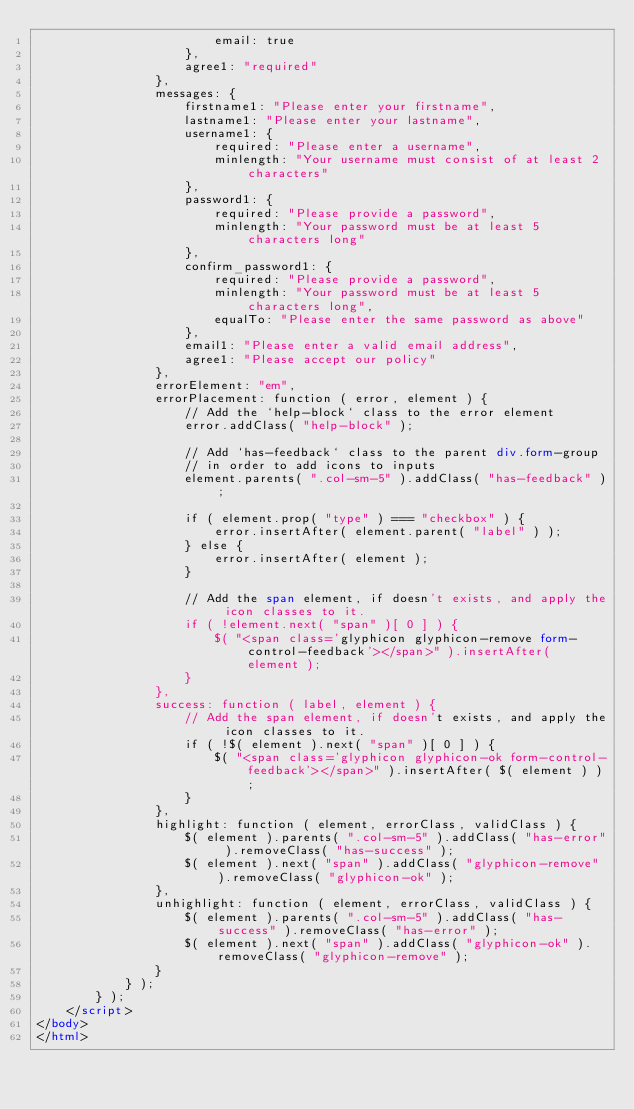<code> <loc_0><loc_0><loc_500><loc_500><_HTML_>						email: true
					},
					agree1: "required"
				},
				messages: {
					firstname1: "Please enter your firstname",
					lastname1: "Please enter your lastname",
					username1: {
						required: "Please enter a username",
						minlength: "Your username must consist of at least 2 characters"
					},
					password1: {
						required: "Please provide a password",
						minlength: "Your password must be at least 5 characters long"
					},
					confirm_password1: {
						required: "Please provide a password",
						minlength: "Your password must be at least 5 characters long",
						equalTo: "Please enter the same password as above"
					},
					email1: "Please enter a valid email address",
					agree1: "Please accept our policy"
				},
				errorElement: "em",
				errorPlacement: function ( error, element ) {
					// Add the `help-block` class to the error element
					error.addClass( "help-block" );

					// Add `has-feedback` class to the parent div.form-group
					// in order to add icons to inputs
					element.parents( ".col-sm-5" ).addClass( "has-feedback" );

					if ( element.prop( "type" ) === "checkbox" ) {
						error.insertAfter( element.parent( "label" ) );
					} else {
						error.insertAfter( element );
					}

					// Add the span element, if doesn't exists, and apply the icon classes to it.
					if ( !element.next( "span" )[ 0 ] ) {
						$( "<span class='glyphicon glyphicon-remove form-control-feedback'></span>" ).insertAfter( element );
					}
				},
				success: function ( label, element ) {
					// Add the span element, if doesn't exists, and apply the icon classes to it.
					if ( !$( element ).next( "span" )[ 0 ] ) {
						$( "<span class='glyphicon glyphicon-ok form-control-feedback'></span>" ).insertAfter( $( element ) );
					}
				},
				highlight: function ( element, errorClass, validClass ) {
					$( element ).parents( ".col-sm-5" ).addClass( "has-error" ).removeClass( "has-success" );
					$( element ).next( "span" ).addClass( "glyphicon-remove" ).removeClass( "glyphicon-ok" );
				},
				unhighlight: function ( element, errorClass, validClass ) {
					$( element ).parents( ".col-sm-5" ).addClass( "has-success" ).removeClass( "has-error" );
					$( element ).next( "span" ).addClass( "glyphicon-ok" ).removeClass( "glyphicon-remove" );
				}
			} );
		} );
	</script>
</body>
</html>
</code> 